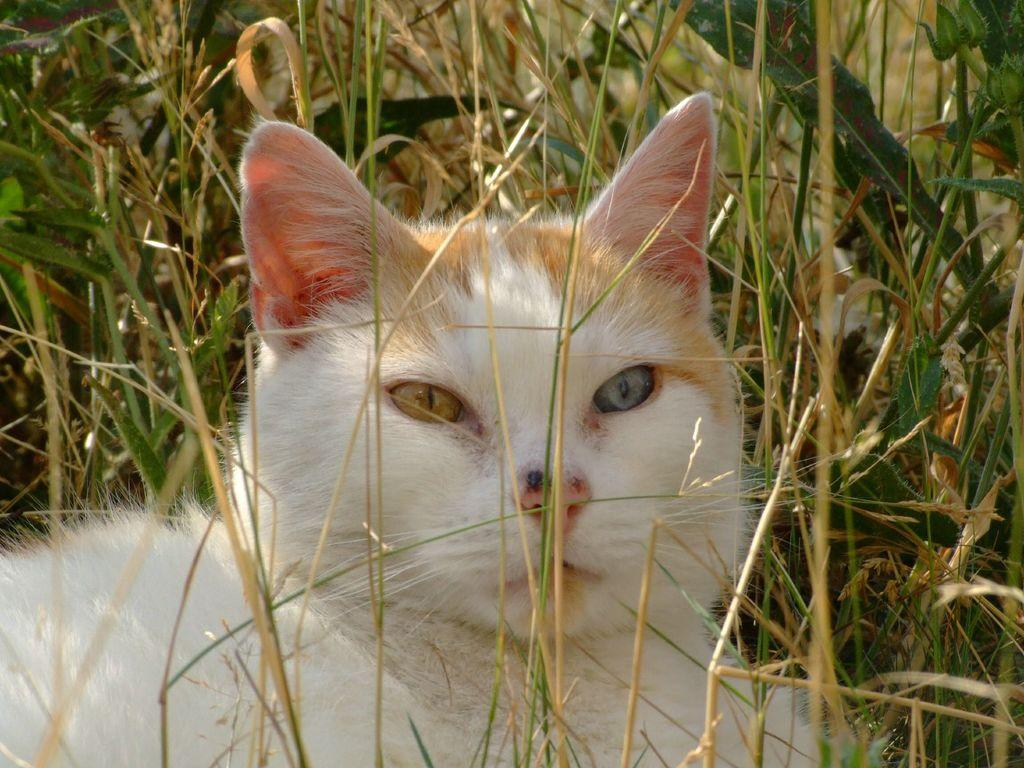What type of animal is in the picture? There is a cat in the picture. Can you describe the describe the color of the cat? The cat is white and cream in color. What type of natural environment can be seen in the picture? There is grass visible in the picture. What type of farm animal is present in the picture? There is no farm animal present in the picture; it features a cat. What type of needle is being used by the cat in the picture? There is no needle present in the picture; it only features a cat and grass. 